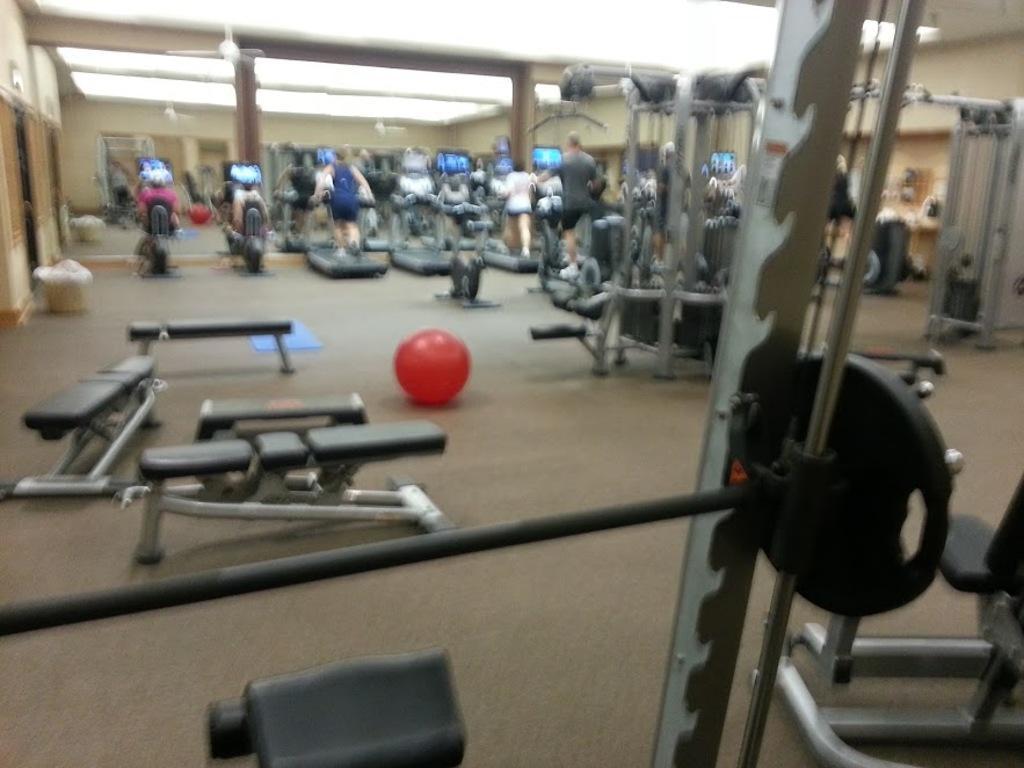Describe this image in one or two sentences. This image is taken in the gym. In this image we can see few people. We can also see the gym equipment. There is a red color ball on the floor. 